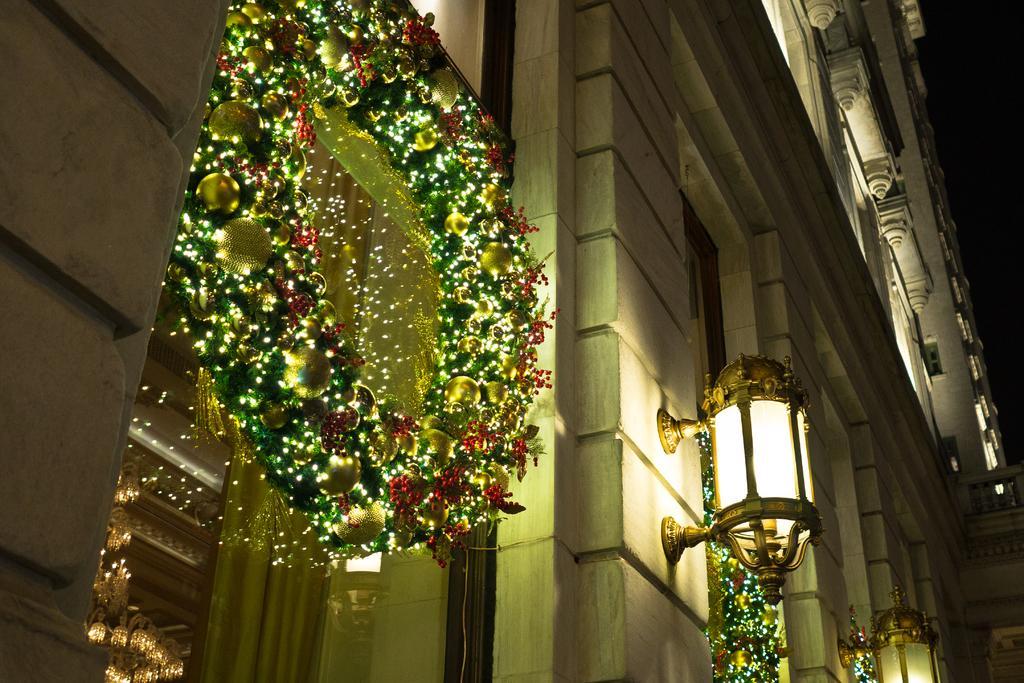Can you describe this image briefly? Here in this picture we can see a building present and we can see lamp posts on the building and we can also see garlands, which are decorated with lights present on the windows of the building. 